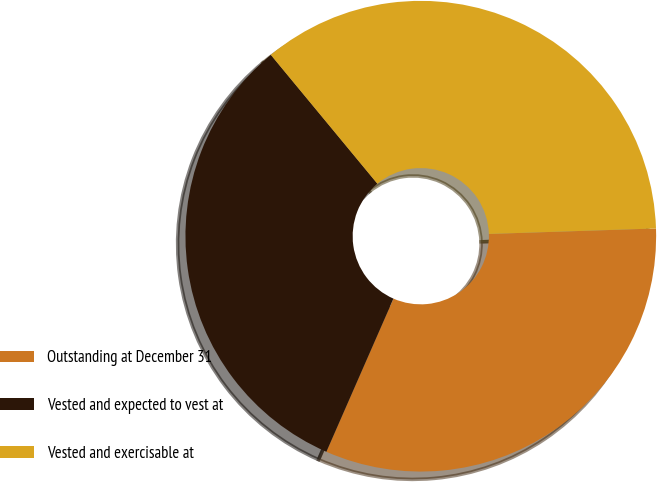<chart> <loc_0><loc_0><loc_500><loc_500><pie_chart><fcel>Outstanding at December 31<fcel>Vested and expected to vest at<fcel>Vested and exercisable at<nl><fcel>32.09%<fcel>32.43%<fcel>35.47%<nl></chart> 